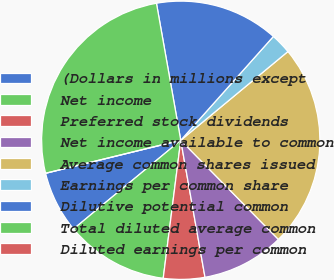Convert chart. <chart><loc_0><loc_0><loc_500><loc_500><pie_chart><fcel>(Dollars in millions except<fcel>Net income<fcel>Preferred stock dividends<fcel>Net income available to common<fcel>Average common shares issued<fcel>Earnings per common share<fcel>Dilutive potential common<fcel>Total diluted average common<fcel>Diluted earnings per common<nl><fcel>7.19%<fcel>11.99%<fcel>4.8%<fcel>9.59%<fcel>23.63%<fcel>2.4%<fcel>14.39%<fcel>26.02%<fcel>0.0%<nl></chart> 